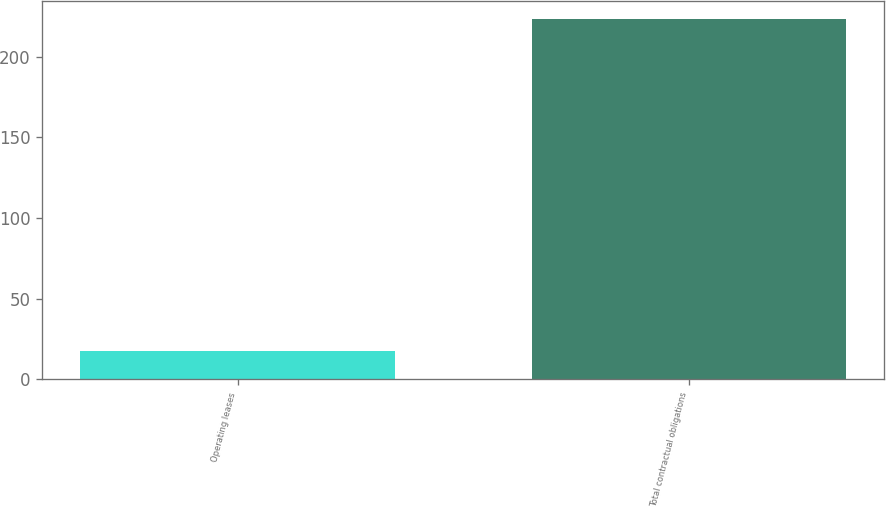Convert chart to OTSL. <chart><loc_0><loc_0><loc_500><loc_500><bar_chart><fcel>Operating leases<fcel>Total contractual obligations<nl><fcel>17.7<fcel>223.2<nl></chart> 